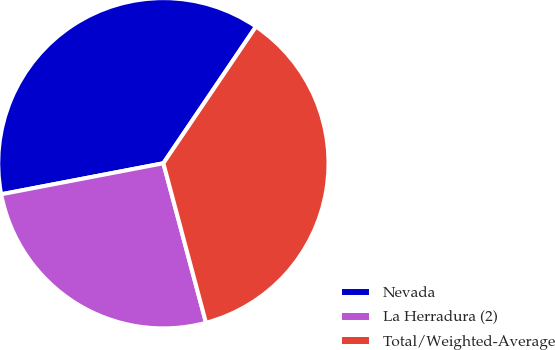Convert chart. <chart><loc_0><loc_0><loc_500><loc_500><pie_chart><fcel>Nevada<fcel>La Herradura (2)<fcel>Total/Weighted-Average<nl><fcel>37.49%<fcel>26.15%<fcel>36.37%<nl></chart> 